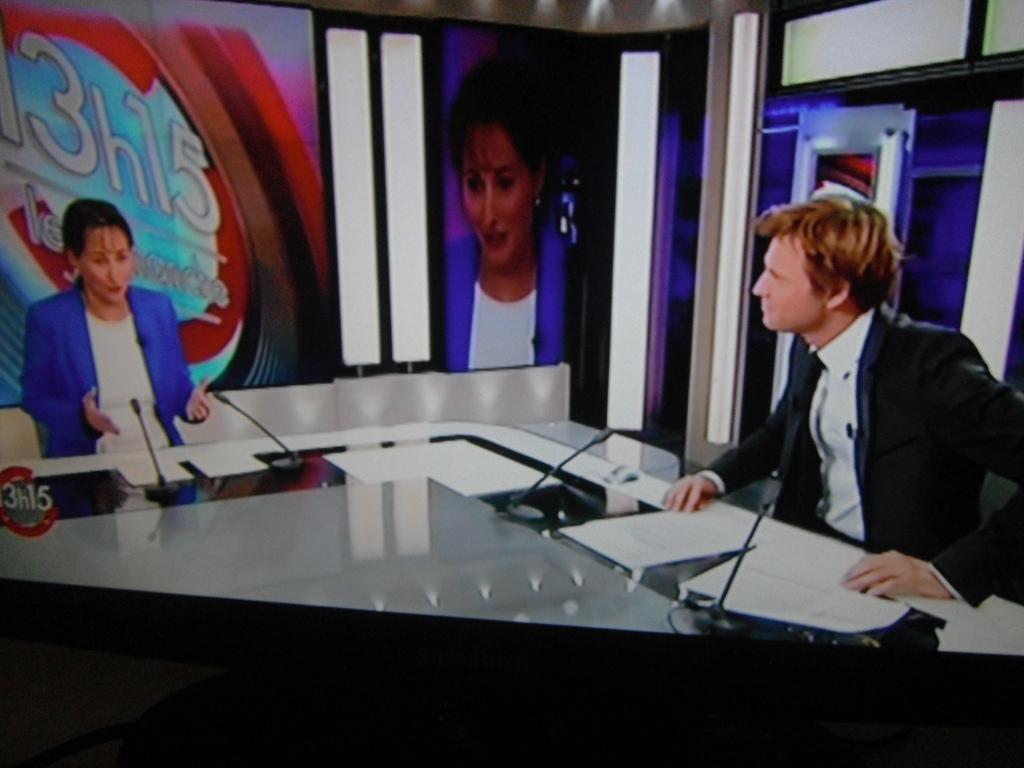Please provide a concise description of this image. I think this picture was taken from the screen. I can see the woman and the man sitting. This is a table with the miles and papers on it. I think these are the posters. 